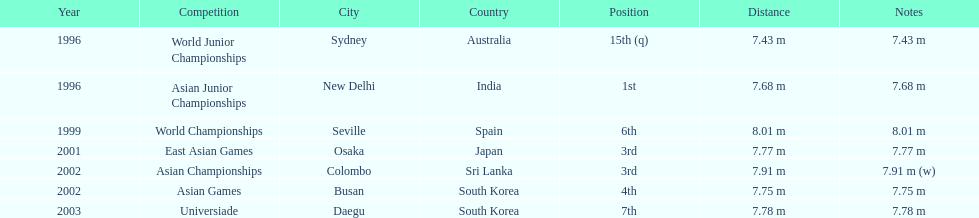What is the number of competitions that have been competed in? 7. 